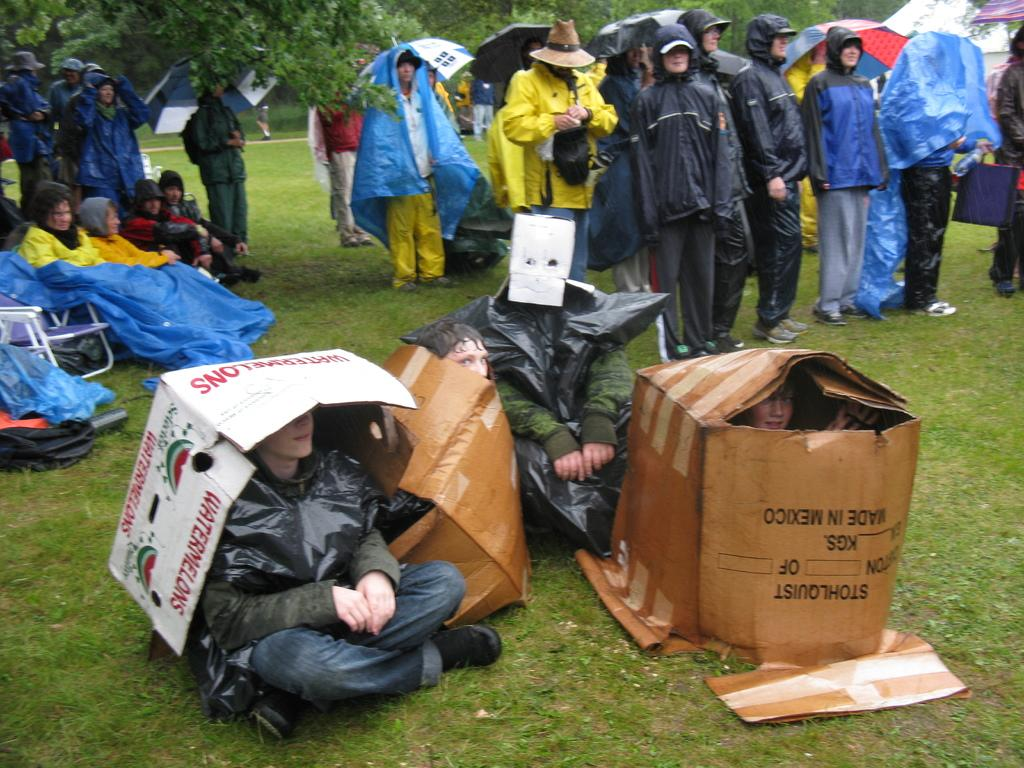What is the main subject of the image? The main subject of the image is a group of people. What can be seen in the background of the image? There are trees at the top of the image. Are there any people sitting in the image? Yes, there are people sitting in the image. What type of terrain is visible in the image? There is a grassy land in the image. What type of frogs can be seen making a discovery in the image? There are no frogs or any discovery-related activities present in the image. 